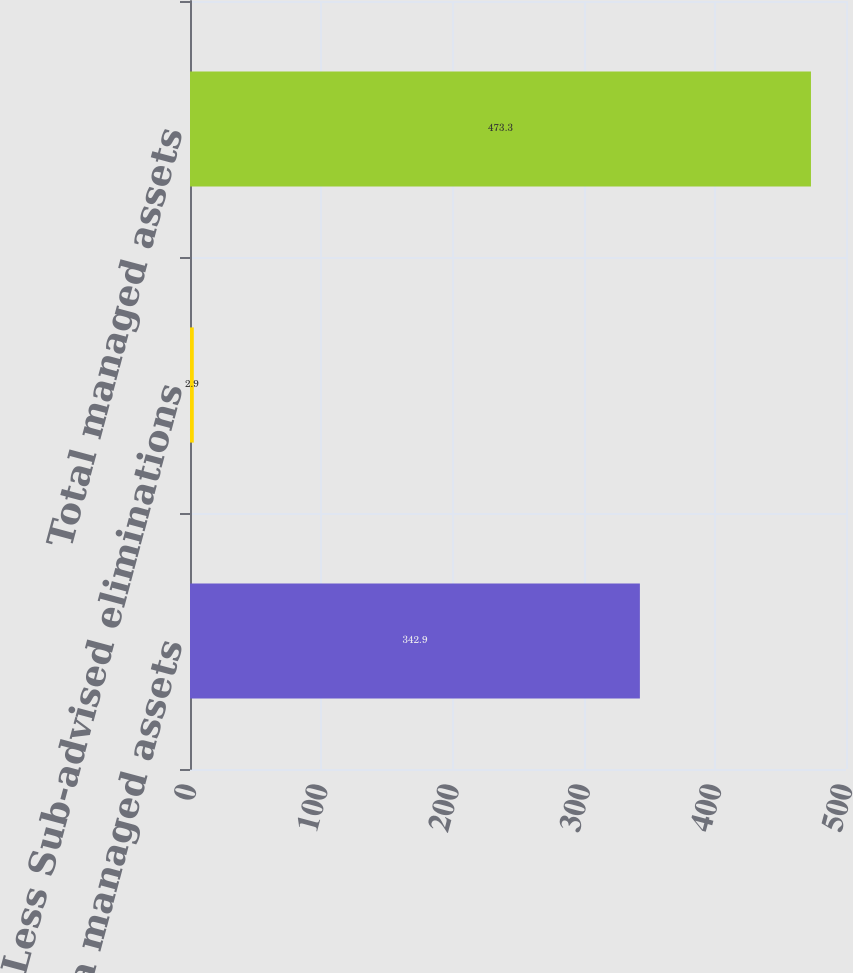Convert chart to OTSL. <chart><loc_0><loc_0><loc_500><loc_500><bar_chart><fcel>Columbia managed assets<fcel>Less Sub-advised eliminations<fcel>Total managed assets<nl><fcel>342.9<fcel>2.9<fcel>473.3<nl></chart> 